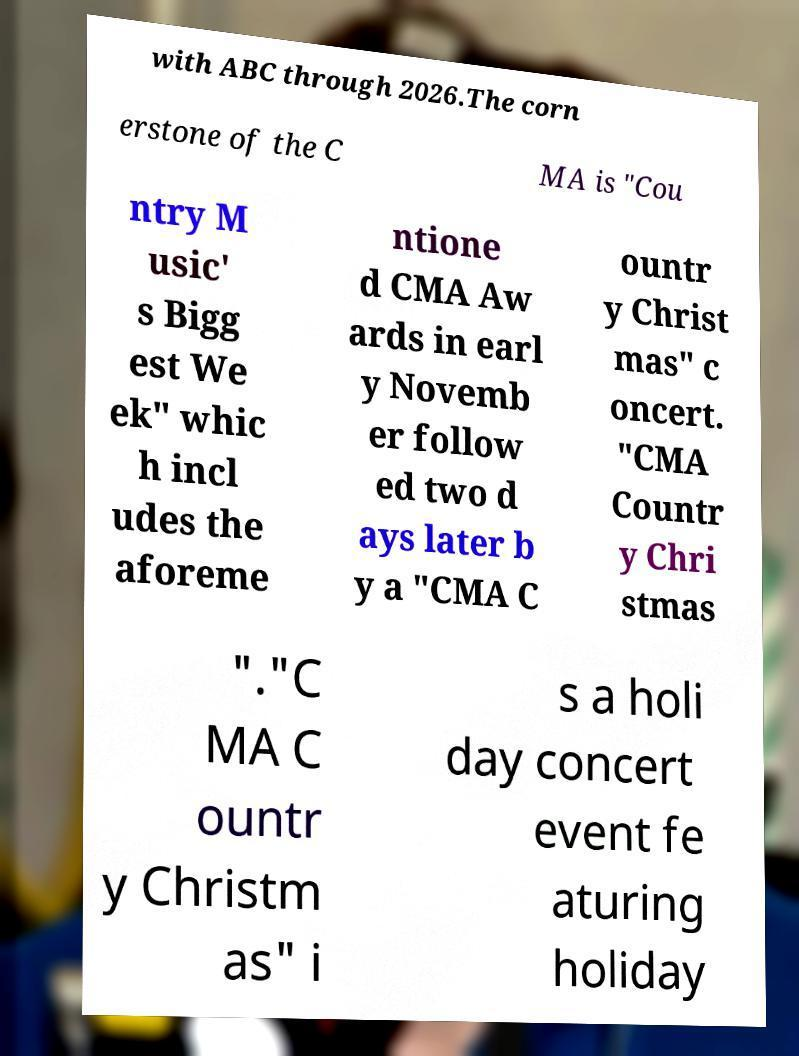Can you accurately transcribe the text from the provided image for me? with ABC through 2026.The corn erstone of the C MA is "Cou ntry M usic' s Bigg est We ek" whic h incl udes the aforeme ntione d CMA Aw ards in earl y Novemb er follow ed two d ays later b y a "CMA C ountr y Christ mas" c oncert. "CMA Countr y Chri stmas "."C MA C ountr y Christm as" i s a holi day concert event fe aturing holiday 